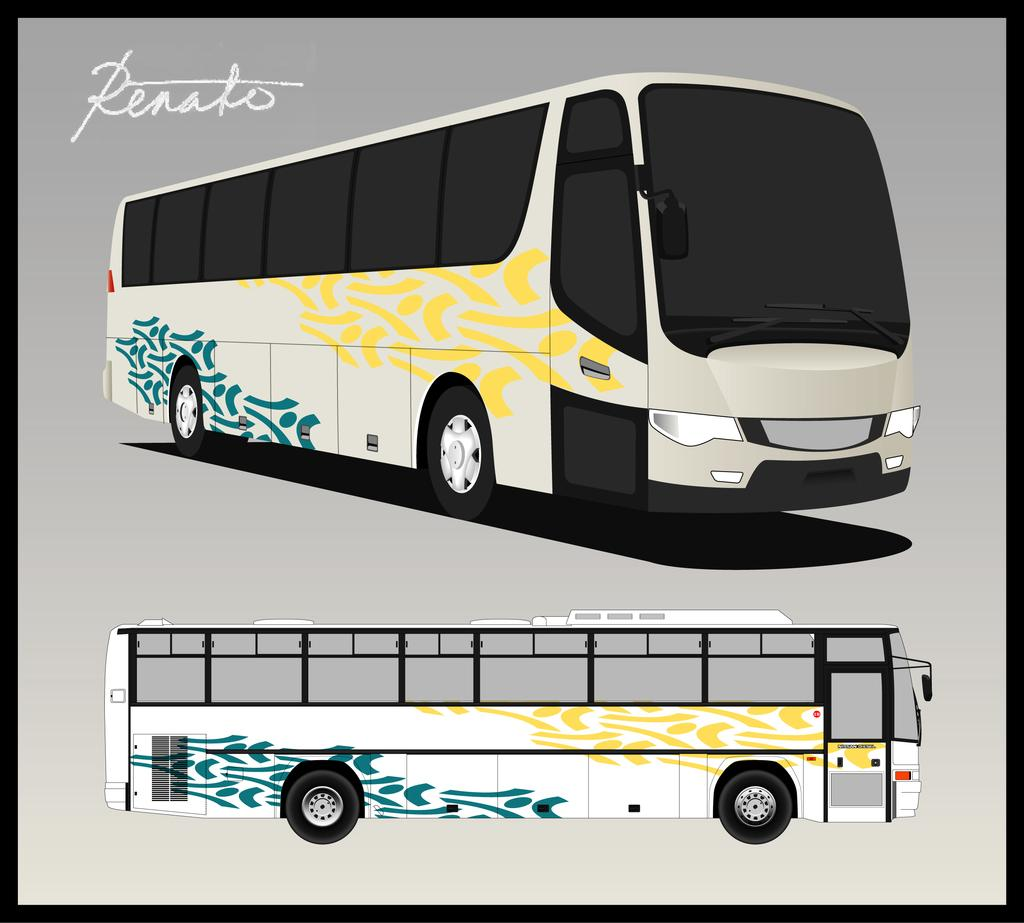<image>
Present a compact description of the photo's key features. A drawing of a bus with the caption Renato. 